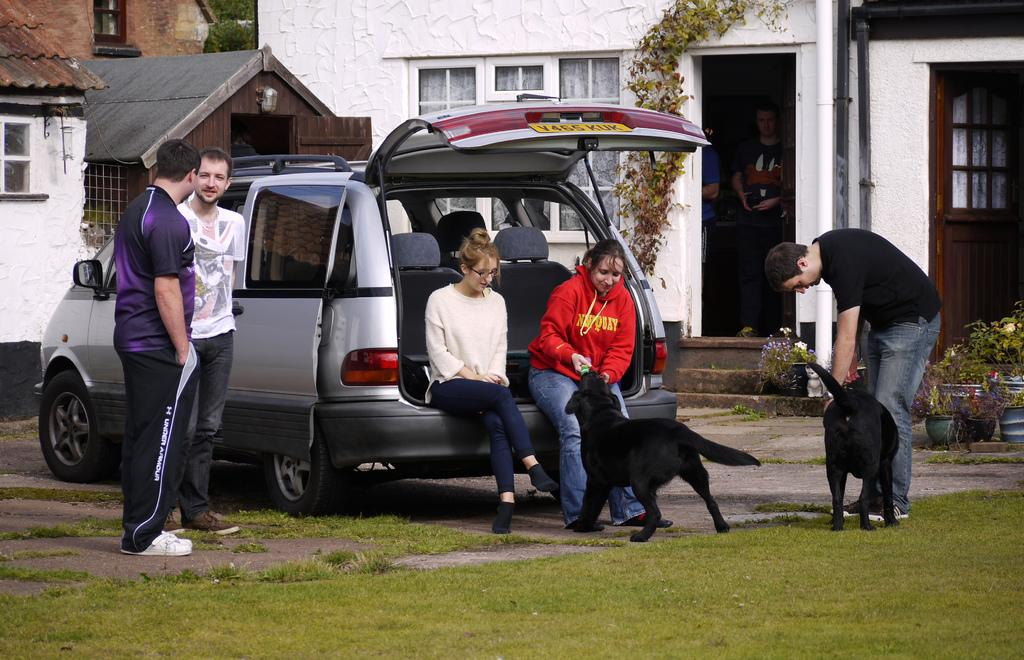What are the people in the car doing in the image? The people in the car are sitting in the image. How many men are standing in the image? There are two men standing in the image. What are the women doing in the image? The women are playing with dogs in the image. What type of ring is the aunt wearing in the image? There is no aunt or ring present in the image. What season is it in the image? The provided facts do not mention the season, so it cannot be determined from the image. 